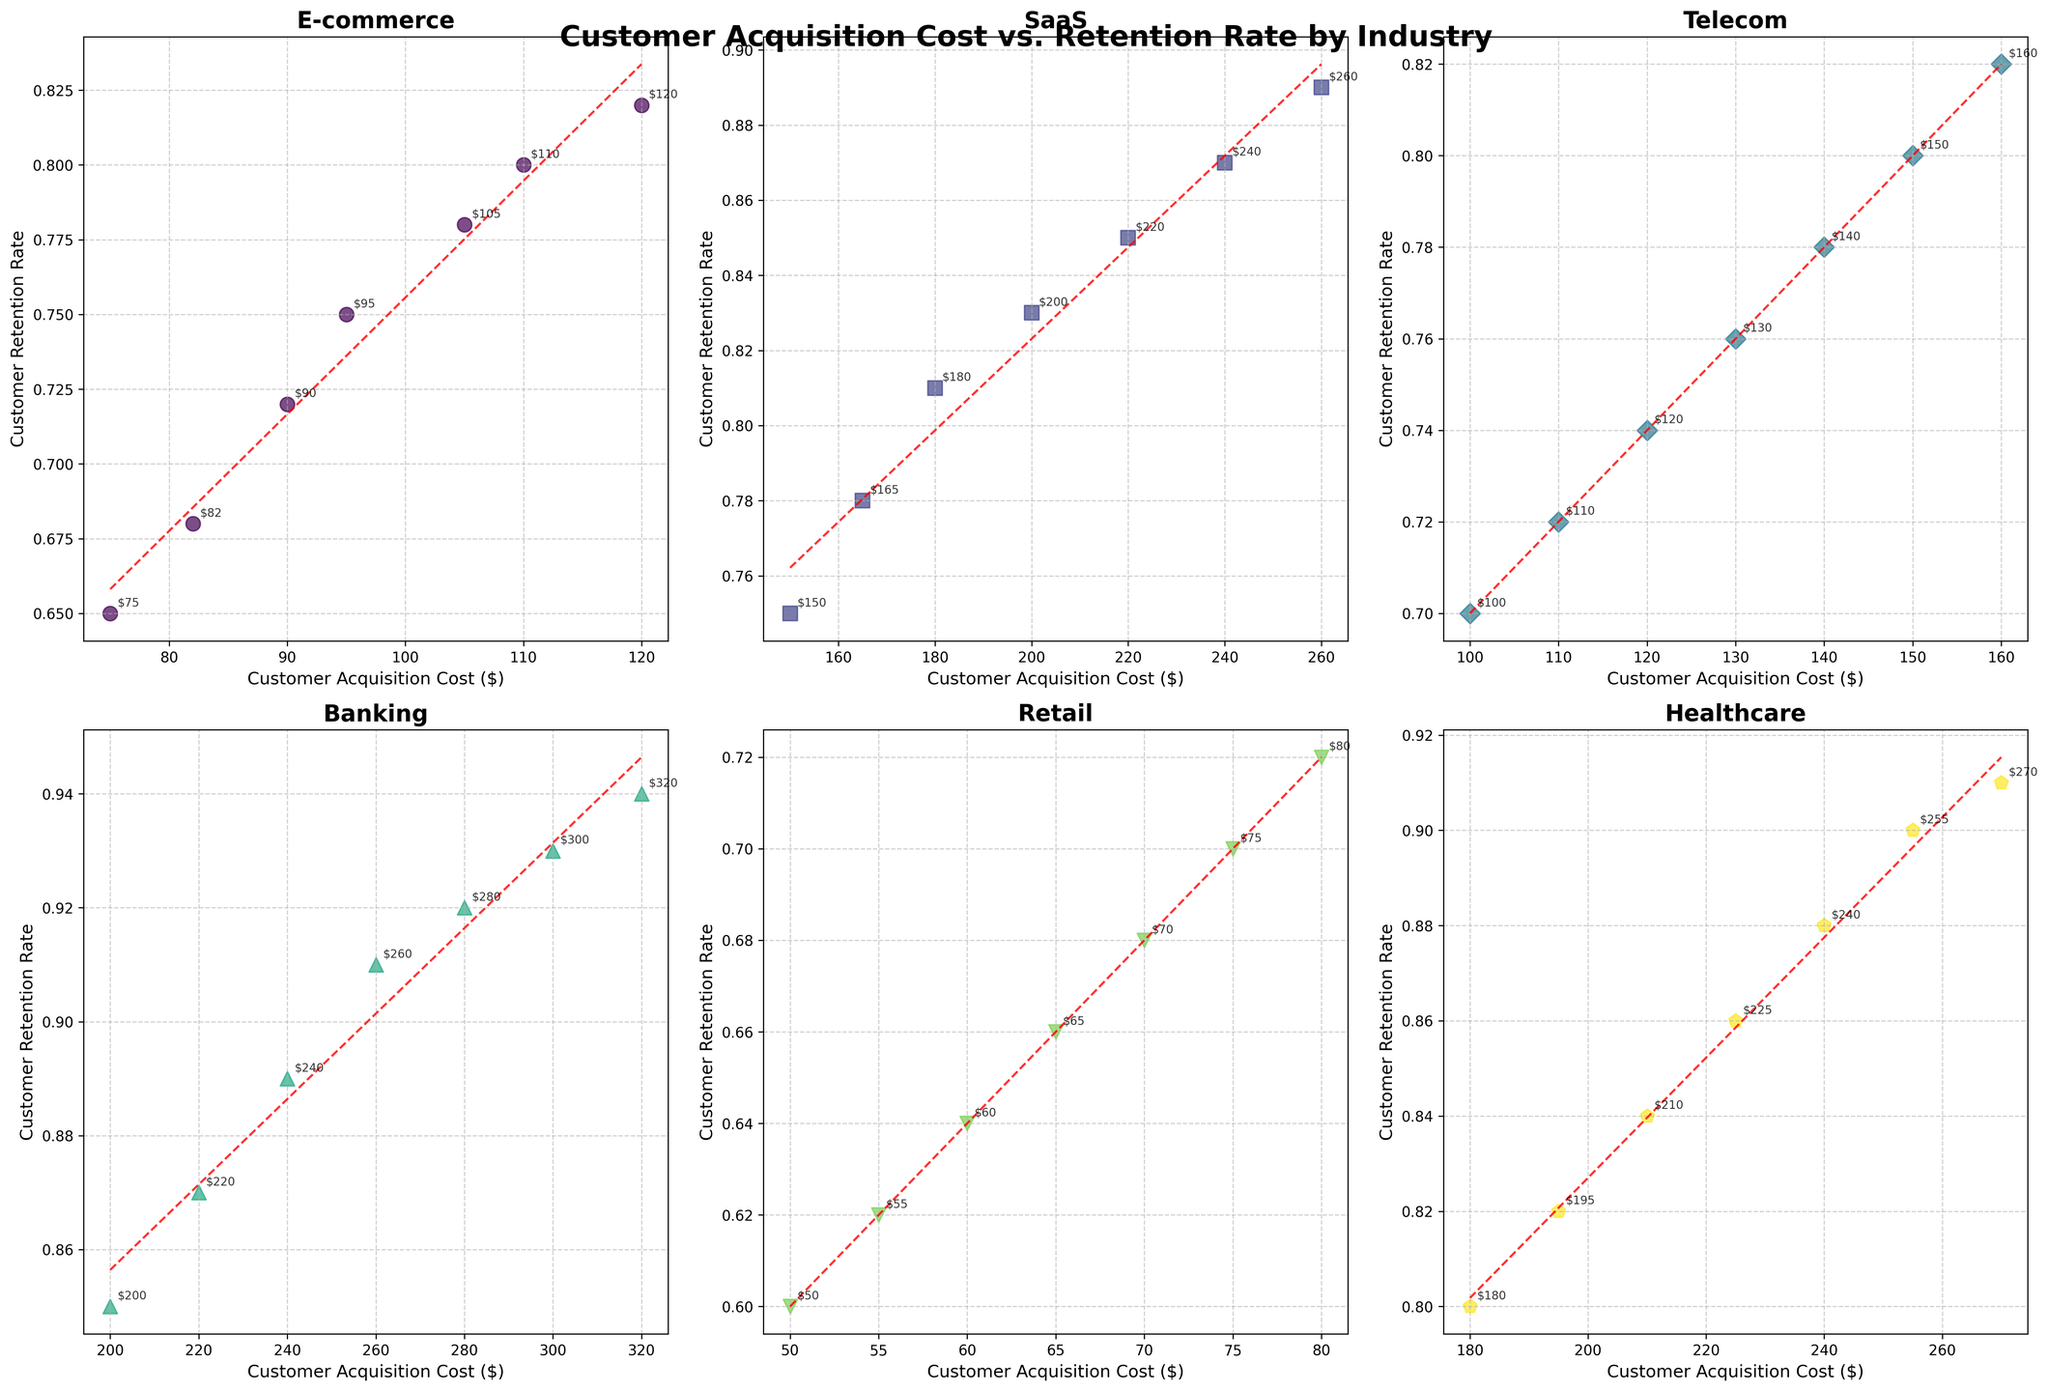Which industry has the highest customer retention rate? By examining the plotted data for different industries, we look for the highest point on the y-axis labeled "Customer Retention Rate." The Banking industry has data points reaching up to 0.94, which is the highest in the figure.
Answer: Banking Which industry has the lowest customer acquisition cost? By examining the plotted data on the x-axis labeled "Customer Acquisition Cost," we look for the lowest point. The Retail industry has data points starting at $50, which is the lowest.
Answer: Retail What is the general trend between customer acquisition costs and retention rates in the Healthcare industry? Observing the scatter plot and the fitted line (red dashed line) within the Healthcare subplot, it appears that as the customer acquisition cost increases, the retention rate also increases. This indicates a positive correlation.
Answer: Positive correlation Compare the customer retention rates between E-commerce and SaaS industries. Which one generally has higher rates? By roughly comparing the y-axis values of both E-commerce and SaaS subplots, it is observed that SaaS retention rates range from 0.75 to 0.89, whereas E-commerce retention rates range from 0.65 to 0.82. Therefore, SaaS generally has higher retention rates.
Answer: SaaS For the Telecom industry, what is the difference in retention rates between the lowest and highest customer acquisition costs? Finding the lowest and highest points on the x-axis in the Telecom subplot, we see that they correspond to retention rates of 0.70 and 0.82, respectively. Subtracting these values: 0.82 - 0.70 = 0.12.
Answer: 0.12 What retention rate is associated with the highest customer acquisition cost in the Banking industry? Looking at the Banking subplot, the highest customer acquisition cost is $320. The corresponding retention rate at this point is 0.94.
Answer: 0.94 Which industry shows a relatively linear relationship between customer acquisition costs and retention rates? Analyzing the fitted red dashed lines in each subplot, the Banking industry has a very linear trend, reflecting a strong linear relationship.
Answer: Banking Comparing E-commerce and Telecom industries, which one has a steeper slope in the fitted line? Observing the slopes of the fitted red dashed lines, E-commerce has a steeper slope compared to Telecom, indicating a more rapid increase in retention rates with increased acquisition costs.
Answer: E-commerce 